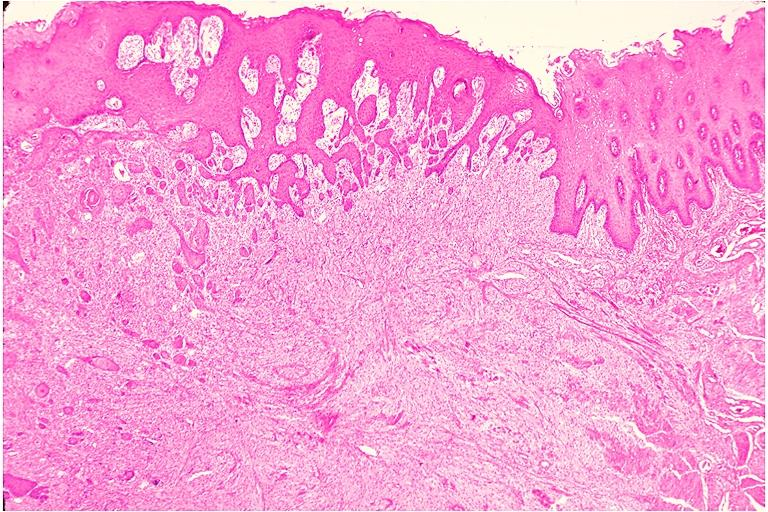does this image show granular cell tumor?
Answer the question using a single word or phrase. Yes 